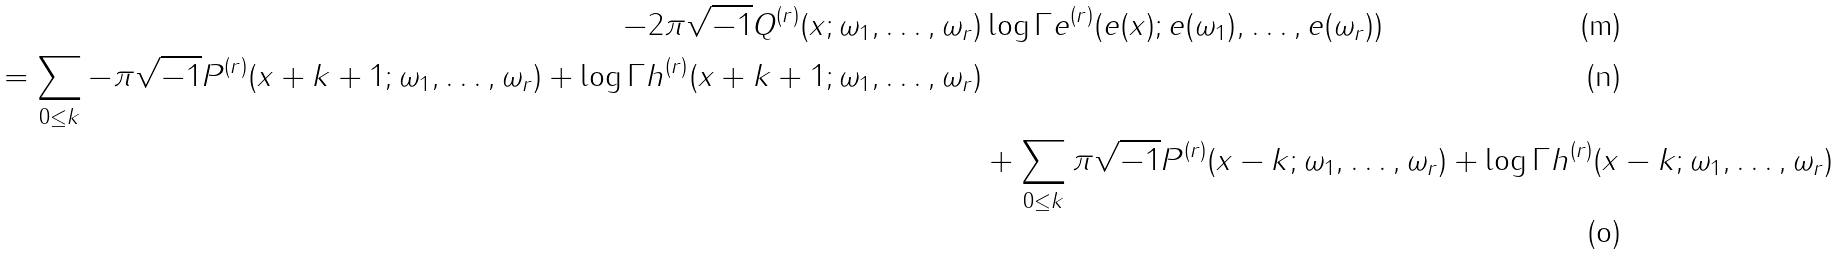Convert formula to latex. <formula><loc_0><loc_0><loc_500><loc_500>- 2 \pi \sqrt { - 1 } Q ^ { ( r ) } ( x ; \omega _ { 1 } , \dots , \omega _ { r } ) & \log \Gamma e ^ { ( r ) } ( e ( x ) ; e ( \omega _ { 1 } ) , \dots , e ( \omega _ { r } ) ) \\ = \sum _ { 0 \leq k } - \pi \sqrt { - 1 } P ^ { ( r ) } ( x + k + 1 ; \omega _ { 1 } , \dots , \omega _ { r } ) + \log \Gamma h ^ { ( r ) } ( x + k + 1 ; \omega _ { 1 } , \dots , \omega _ { r } ) \\ & + \sum _ { 0 \leq k } \pi \sqrt { - 1 } P ^ { ( r ) } ( x - k ; \omega _ { 1 } , \dots , \omega _ { r } ) + \log \Gamma h ^ { ( r ) } ( x - k ; \omega _ { 1 } , \dots , \omega _ { r } )</formula> 